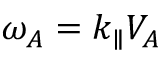Convert formula to latex. <formula><loc_0><loc_0><loc_500><loc_500>\omega _ { A } = k _ { \| } V _ { A }</formula> 